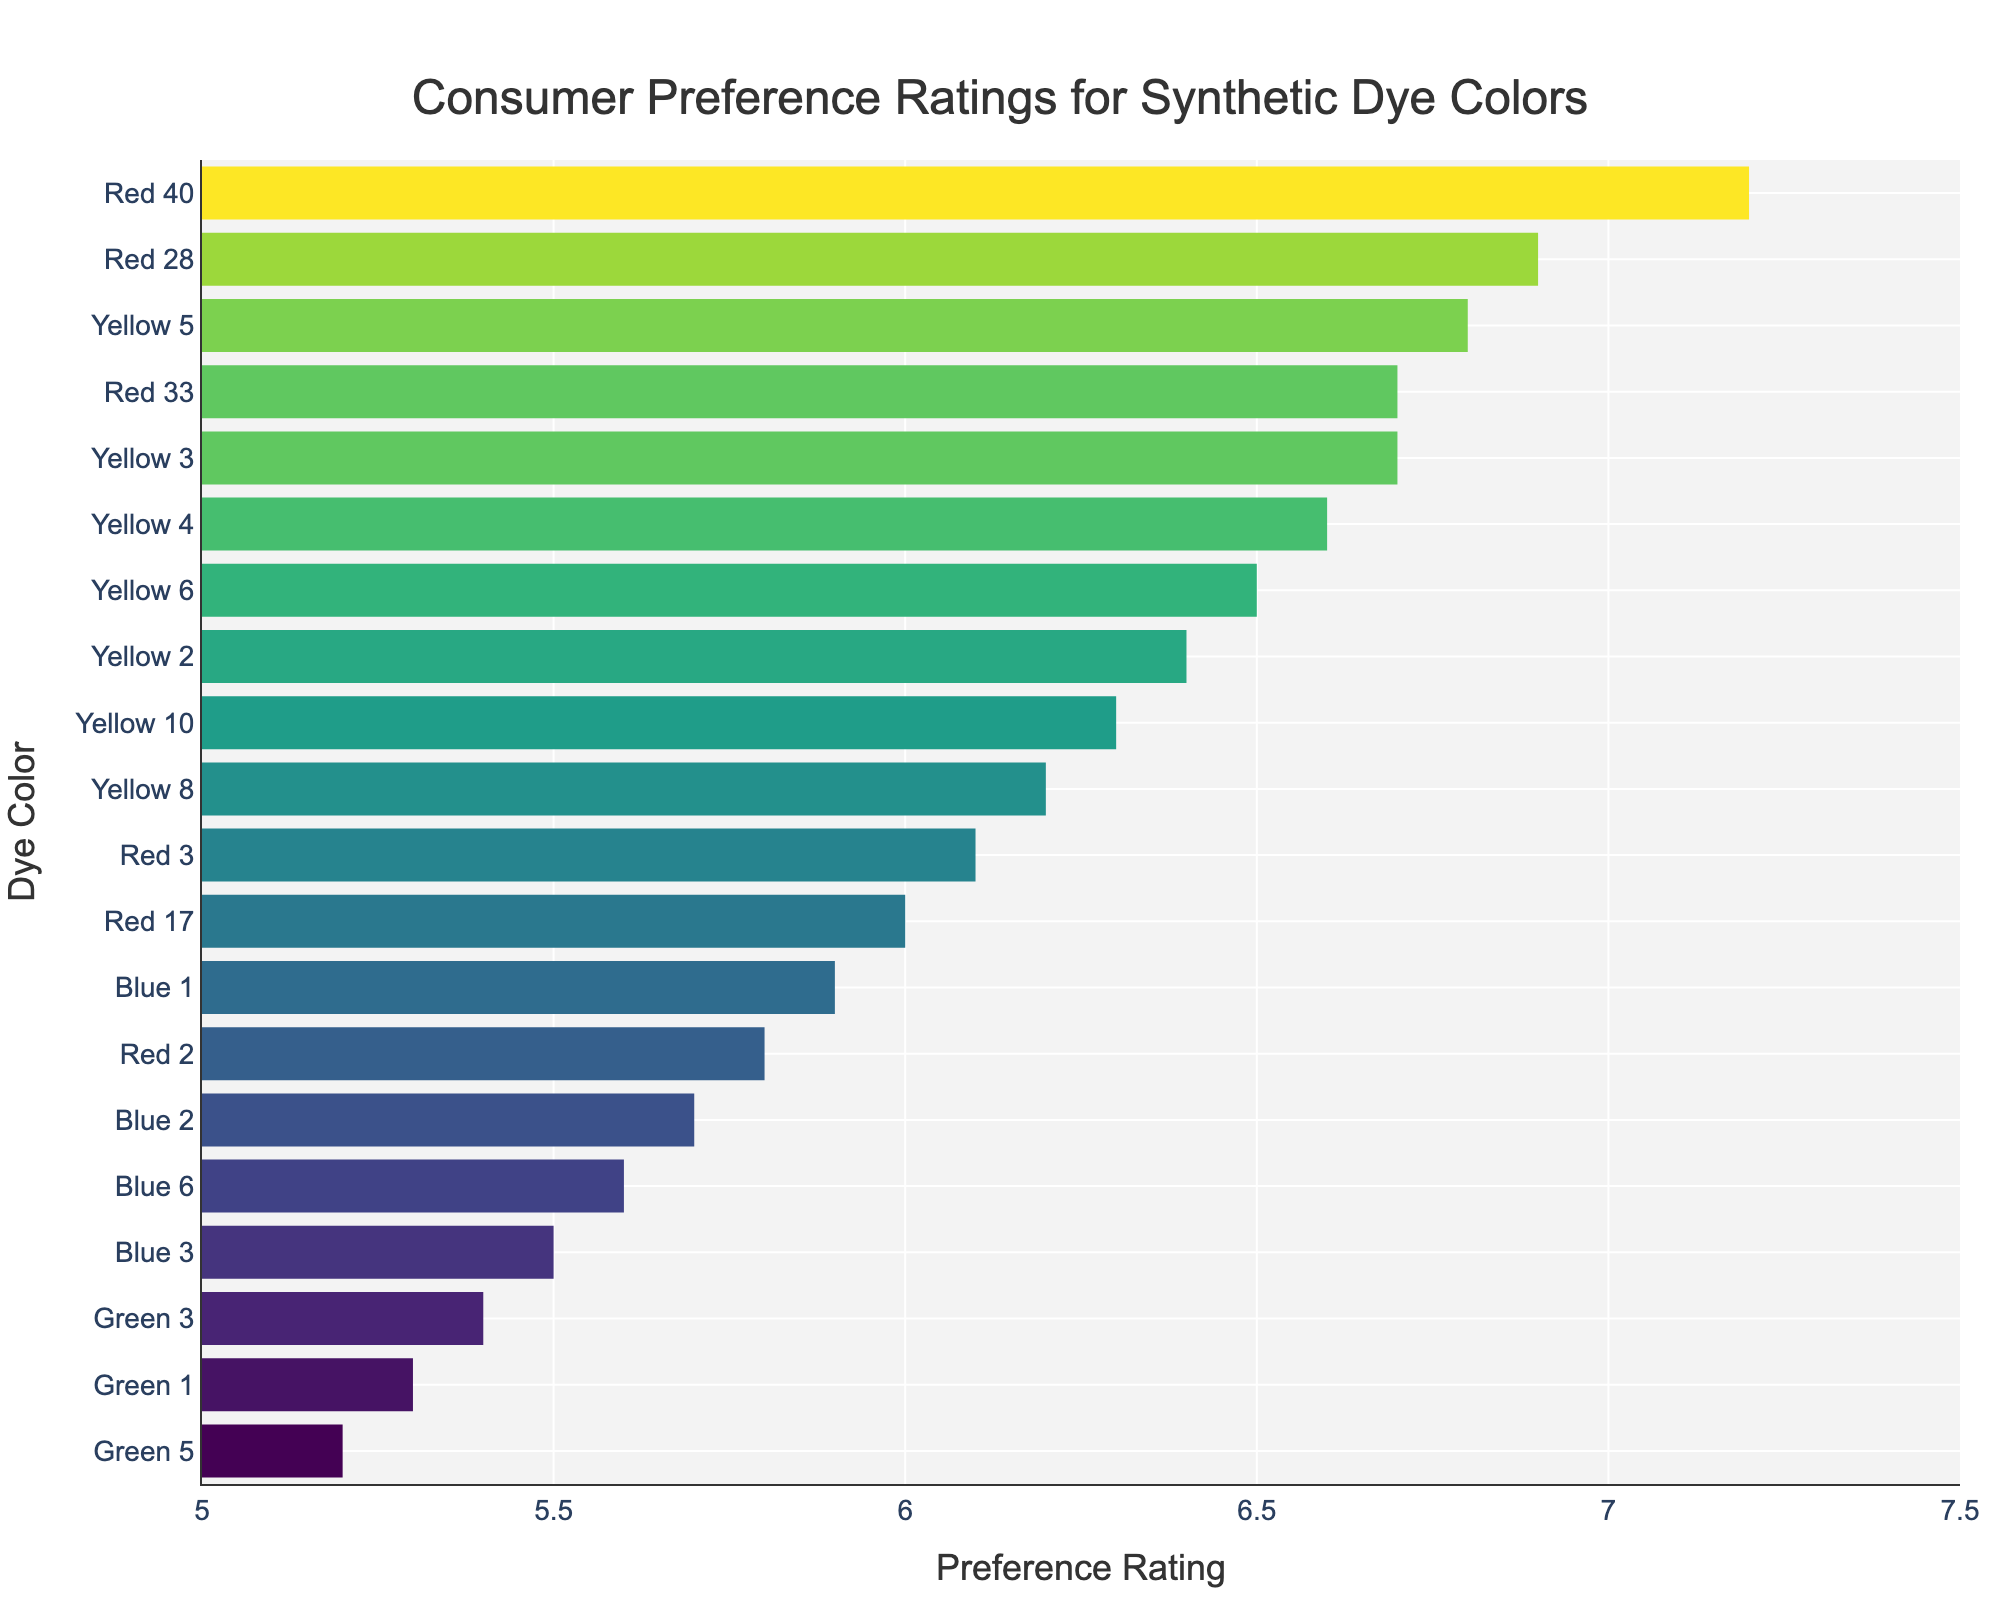What is the title of the figure? The title is placed at the top center of the figure. It is written clearly to indicate the content being visualized.
Answer: "Consumer Preference Ratings for Synthetic Dye Colors" What is the x-axis label? The x-axis label is displayed below the x-axis and describes the horizontal variable depicted in the plot.
Answer: "Preference Rating" What is the y-axis label? The y-axis label is displayed to the left of the y-axis and describes the vertical variable depicted in the plot.
Answer: "Dye Color" Which synthetic dye color has the highest consumer preference rating? By looking at the bar with the longest length towards the right end of the x-axis, we can identify the highest consumer preference rating.
Answer: Red 40 What is the range of preference ratings in the plot? The range can be determined by checking the minimum and maximum values represented on the x-axis and their corresponding bars.
Answer: 5.2 to 7.2 Which color has the lowest preference rating? Identify the bar with the shortest length towards the left end of the x-axis to find the lowest preference rating.
Answer: Green 5 